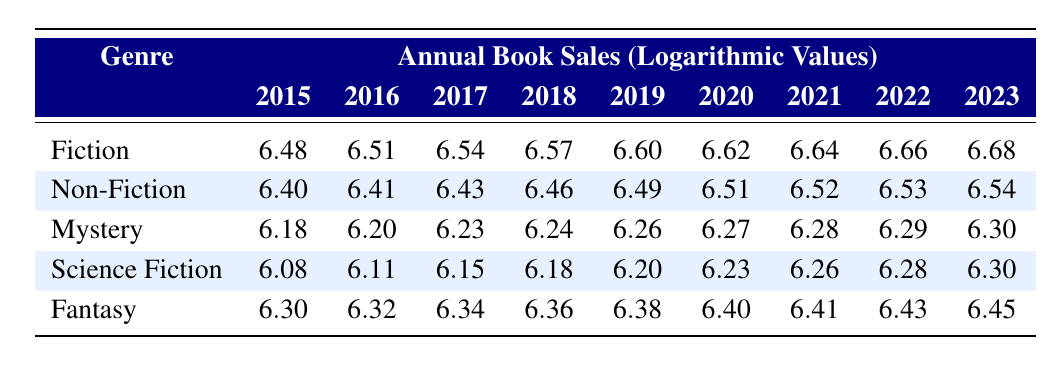What was the Fiction book sales in 2020? The table shows the annual book sales of different genres by year. In the year 2020, the sales for Fiction are listed as 6.62 (logarithmic value).
Answer: 6.62 Which genre had the highest sales in 2023? In the year 2023, the Fiction genre has the highest logarithmic sales value of 6.68 when compared to other genres.
Answer: Fiction What is the difference in sales between Fantasy in 2022 and Mystery in 2023? First, we find the sales for Fantasy in 2022, which is 6.43, and for Mystery in 2023, which is 6.30. The difference is calculated as 6.43 - 6.30 = 0.13.
Answer: 0.13 Did Non-Fiction book sales increase every year from 2015 to 2023? By examining the Non-Fiction sales values from 2015 to 2023, we see an increasing trend each year without any decrease, confirming that sales did increase every year.
Answer: Yes What was the average sales of Science Fiction from 2015 to 2019? The sales values for Science Fiction from 2015 to 2019 are 6.08, 6.11, 6.15, 6.18, and 6.20. To find the average, we add these values: 6.08 + 6.11 + 6.15 + 6.18 + 6.20 = 30.92, then divide by 5, which gives 30.92 / 5 = 6.184.
Answer: 6.184 Which genre had the least logarithmic value in 2017? In 2017, the logarithmic values for the genres are 6.54 for Fiction, 6.43 for Non-Fiction, 6.23 for Mystery, 6.15 for Science Fiction, and 6.34 for Fantasy. The least is Mystery with 6.23.
Answer: Mystery What is the total sum of the logarithmic values for Fantasy from 2015 to 2023? The values for Fantasy from 2015 to 2023 are 6.30, 6.32, 6.34, 6.36, 6.38, 6.40, 6.41, 6.43, and 6.45. We sum these: 6.30 + 6.32 + 6.34 + 6.36 + 6.38 + 6.40 + 6.41 + 6.43 + 6.45 = 51.69.
Answer: 51.69 In how many years did the sales for Mystery exceed 6.25? Checking the values for Mystery across the years, we see that they are 6.18, 6.20, 6.23, 6.24, 6.26, 6.27, 6.28, 6.29, and 6.30. The years where it exceeds 6.25 are 2018, 2019, 2020, 2021, 2022, and 2023, totaling 6 years.
Answer: 6 